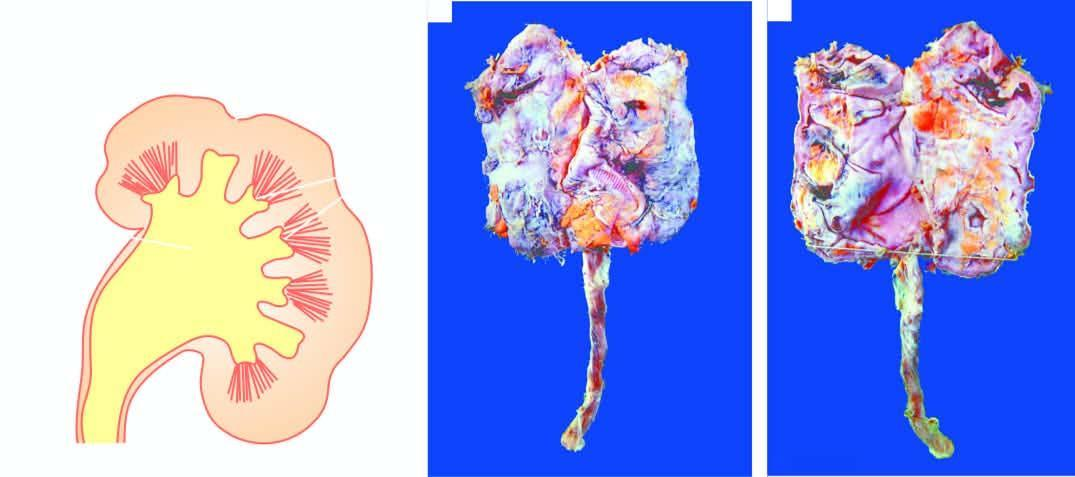what is in chronic pyelonephritis with calyectasis?
Answer the question using a single word or phrase. Small contracted kidney 